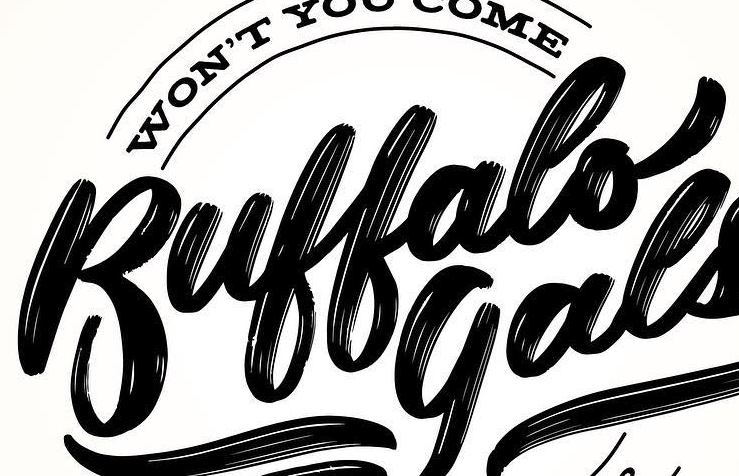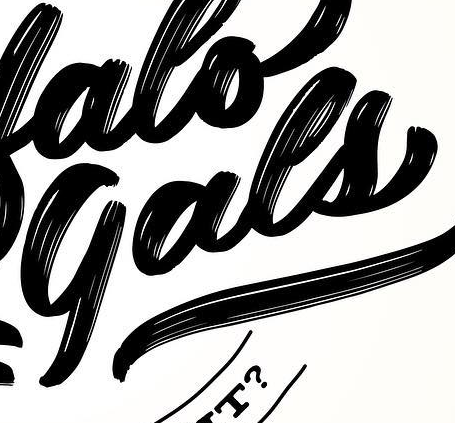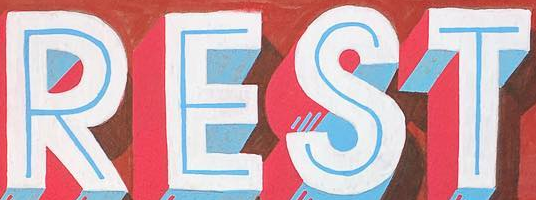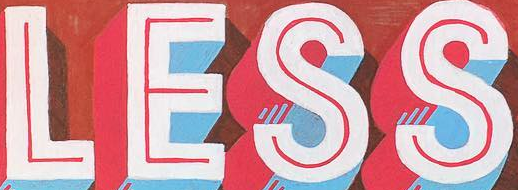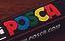What words can you see in these images in sequence, separated by a semicolon? Buffalo; gals; REST; LESS; POSCA 